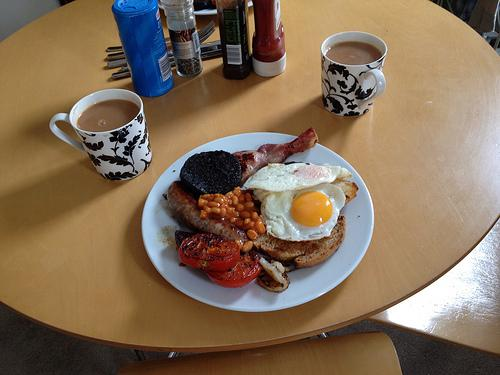Question: what shape is the dish?
Choices:
A. Square.
B. Rectangular.
C. Octagonal.
D. Round.
Answer with the letter. Answer: D Question: where is the plate?
Choices:
A. In the steamer.
B. On a table.
C. In the oven.
D. Beside the microwave.
Answer with the letter. Answer: B Question: what is in the mugs?
Choices:
A. Coffee.
B. Broth.
C. Hot Milk.
D. Ice tea.
Answer with the letter. Answer: A Question: what color are the mugs?
Choices:
A. Green and blue.
B. Black and white.
C. Brown and gold.
D. Yellow and black.
Answer with the letter. Answer: B Question: what food is white and yellow?
Choices:
A. A banana.
B. An egg.
C. A squash.
D. A cake.
Answer with the letter. Answer: B Question: what is the red food?
Choices:
A. Peppers.
B. Stew.
C. Hot sauce.
D. Tomato slices.
Answer with the letter. Answer: D 